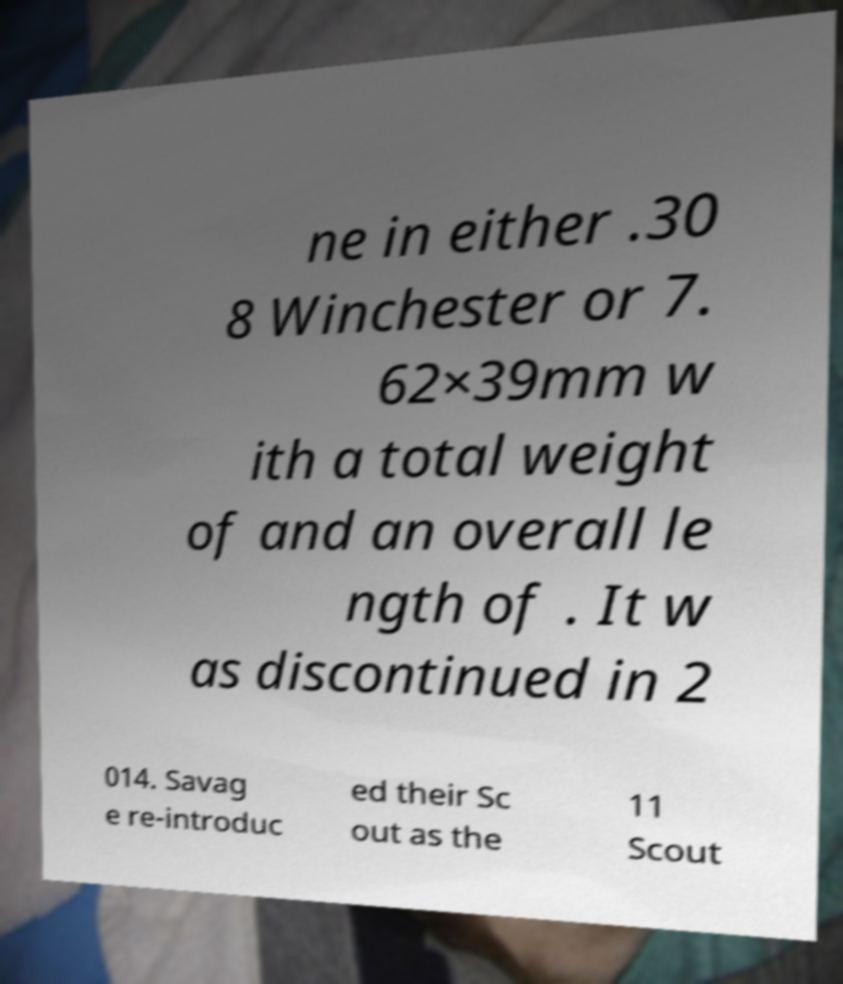There's text embedded in this image that I need extracted. Can you transcribe it verbatim? ne in either .30 8 Winchester or 7. 62×39mm w ith a total weight of and an overall le ngth of . It w as discontinued in 2 014. Savag e re-introduc ed their Sc out as the 11 Scout 